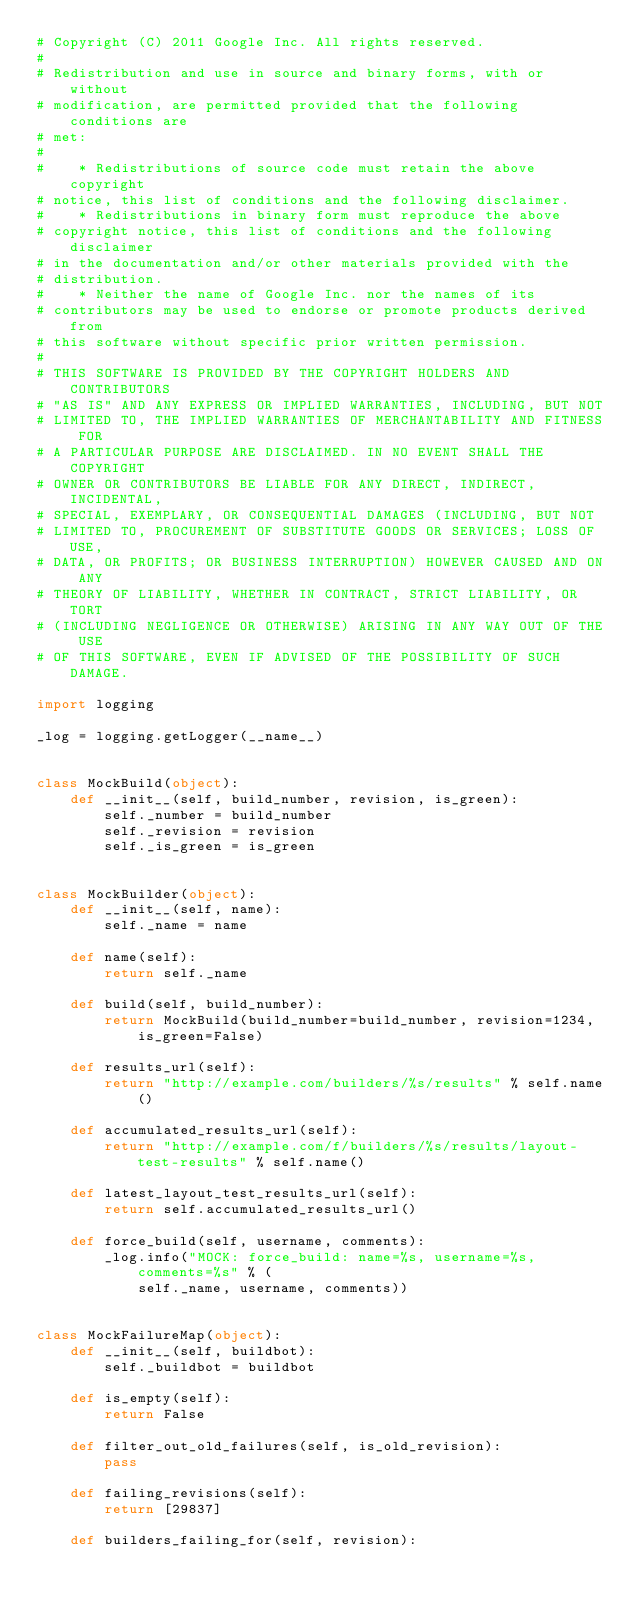Convert code to text. <code><loc_0><loc_0><loc_500><loc_500><_Python_># Copyright (C) 2011 Google Inc. All rights reserved.
#
# Redistribution and use in source and binary forms, with or without
# modification, are permitted provided that the following conditions are
# met:
#
#    * Redistributions of source code must retain the above copyright
# notice, this list of conditions and the following disclaimer.
#    * Redistributions in binary form must reproduce the above
# copyright notice, this list of conditions and the following disclaimer
# in the documentation and/or other materials provided with the
# distribution.
#    * Neither the name of Google Inc. nor the names of its
# contributors may be used to endorse or promote products derived from
# this software without specific prior written permission.
#
# THIS SOFTWARE IS PROVIDED BY THE COPYRIGHT HOLDERS AND CONTRIBUTORS
# "AS IS" AND ANY EXPRESS OR IMPLIED WARRANTIES, INCLUDING, BUT NOT
# LIMITED TO, THE IMPLIED WARRANTIES OF MERCHANTABILITY AND FITNESS FOR
# A PARTICULAR PURPOSE ARE DISCLAIMED. IN NO EVENT SHALL THE COPYRIGHT
# OWNER OR CONTRIBUTORS BE LIABLE FOR ANY DIRECT, INDIRECT, INCIDENTAL,
# SPECIAL, EXEMPLARY, OR CONSEQUENTIAL DAMAGES (INCLUDING, BUT NOT
# LIMITED TO, PROCUREMENT OF SUBSTITUTE GOODS OR SERVICES; LOSS OF USE,
# DATA, OR PROFITS; OR BUSINESS INTERRUPTION) HOWEVER CAUSED AND ON ANY
# THEORY OF LIABILITY, WHETHER IN CONTRACT, STRICT LIABILITY, OR TORT
# (INCLUDING NEGLIGENCE OR OTHERWISE) ARISING IN ANY WAY OUT OF THE USE
# OF THIS SOFTWARE, EVEN IF ADVISED OF THE POSSIBILITY OF SUCH DAMAGE.

import logging

_log = logging.getLogger(__name__)


class MockBuild(object):
    def __init__(self, build_number, revision, is_green):
        self._number = build_number
        self._revision = revision
        self._is_green = is_green


class MockBuilder(object):
    def __init__(self, name):
        self._name = name

    def name(self):
        return self._name

    def build(self, build_number):
        return MockBuild(build_number=build_number, revision=1234, is_green=False)

    def results_url(self):
        return "http://example.com/builders/%s/results" % self.name()

    def accumulated_results_url(self):
        return "http://example.com/f/builders/%s/results/layout-test-results" % self.name()

    def latest_layout_test_results_url(self):
        return self.accumulated_results_url()

    def force_build(self, username, comments):
        _log.info("MOCK: force_build: name=%s, username=%s, comments=%s" % (
            self._name, username, comments))


class MockFailureMap(object):
    def __init__(self, buildbot):
        self._buildbot = buildbot

    def is_empty(self):
        return False

    def filter_out_old_failures(self, is_old_revision):
        pass

    def failing_revisions(self):
        return [29837]

    def builders_failing_for(self, revision):</code> 